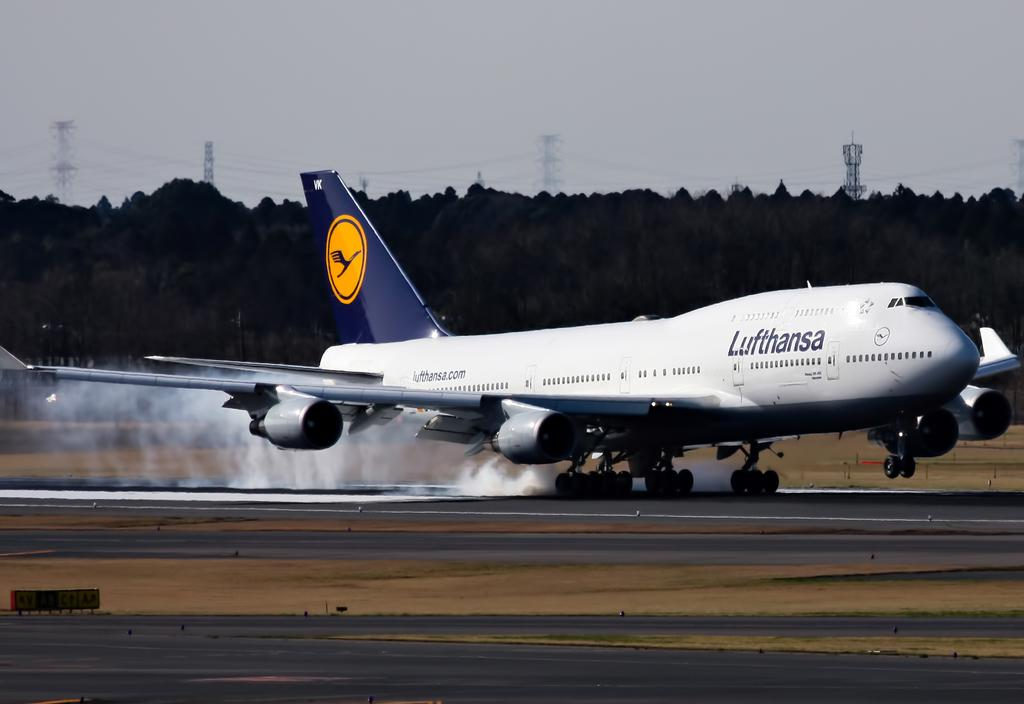<image>
Summarize the visual content of the image. the Lufthansa plans is stopping on the tarmack 